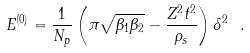Convert formula to latex. <formula><loc_0><loc_0><loc_500><loc_500>E ^ { ( 0 ) } = \frac { 1 } { N _ { p } } \left ( \pi \sqrt { \beta _ { 1 } \beta _ { 2 } } - \frac { Z ^ { 2 } t ^ { 2 } } { \rho _ { s } } \right ) \delta ^ { 2 } \ .</formula> 